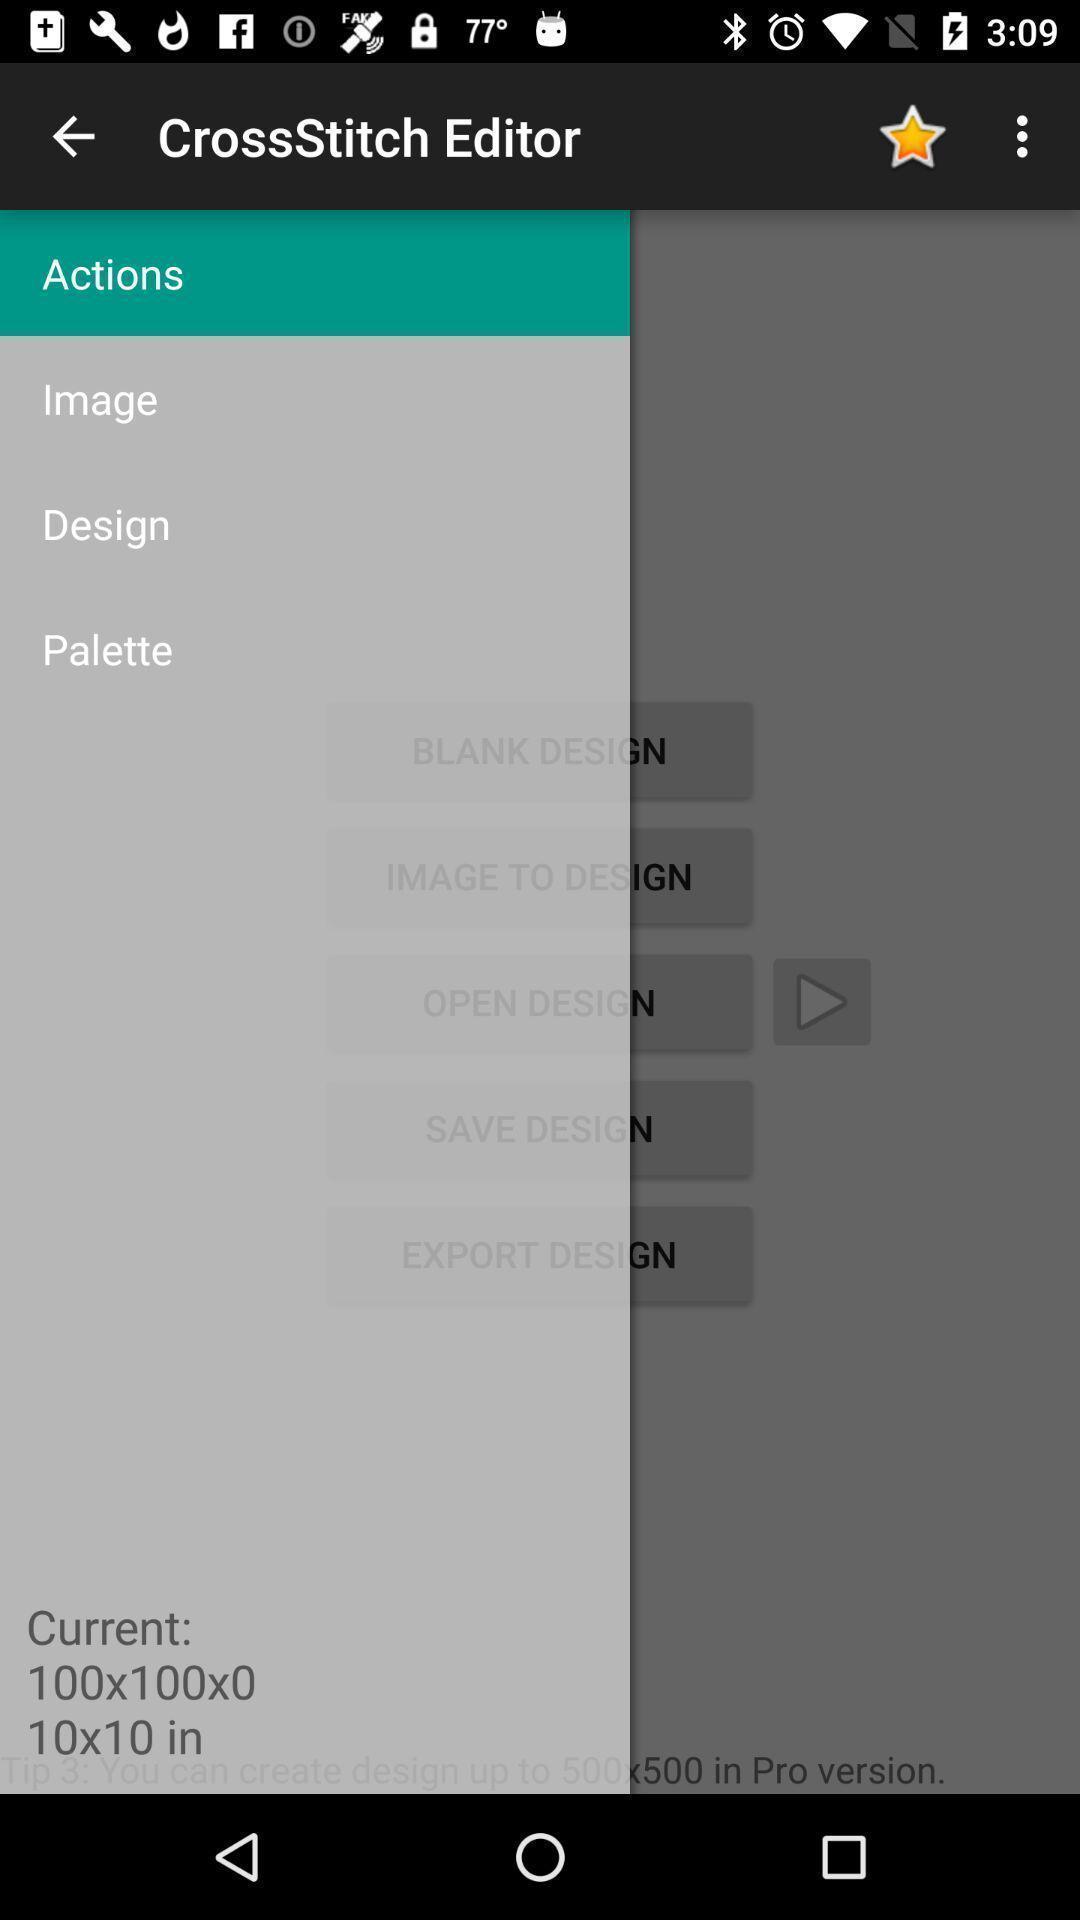What details can you identify in this image? Page showing list of options in app. 